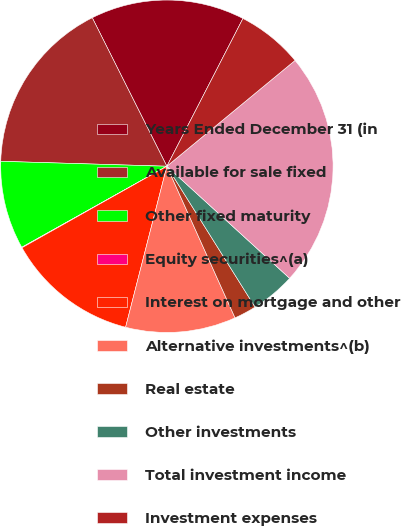Convert chart to OTSL. <chart><loc_0><loc_0><loc_500><loc_500><pie_chart><fcel>Years Ended December 31 (in<fcel>Available for sale fixed<fcel>Other fixed maturity<fcel>Equity securities^(a)<fcel>Interest on mortgage and other<fcel>Alternative investments^(b)<fcel>Real estate<fcel>Other investments<fcel>Total investment income<fcel>Investment expenses<nl><fcel>14.98%<fcel>17.12%<fcel>8.58%<fcel>0.05%<fcel>12.85%<fcel>10.72%<fcel>2.18%<fcel>4.32%<fcel>22.76%<fcel>6.45%<nl></chart> 